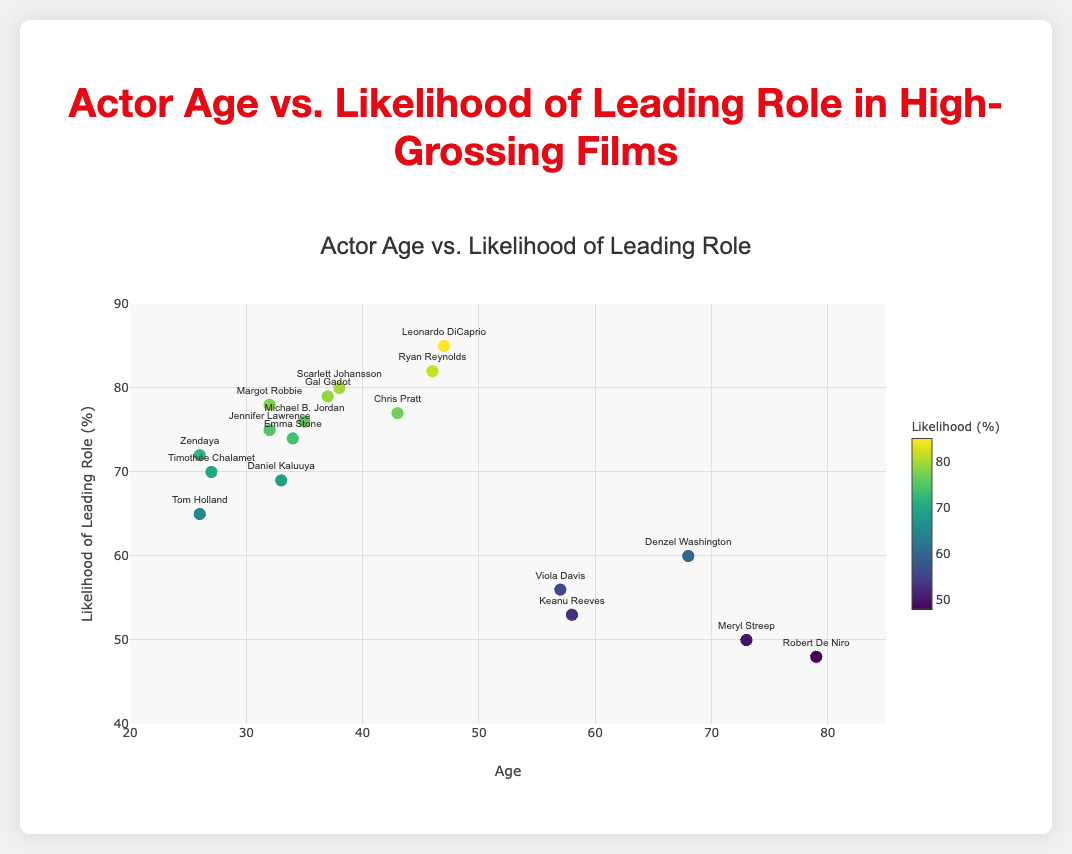what are the age ranges depicted on the x-axis? The x-axis labeled 'Age' ranges from 20 to 85 based on its axis ticks and grid lines.
Answer: 20 to 85 Which actor has the highest likelihood of being cast in a leading role? By identifying the highest y-axis value and reading the corresponding text label, we see Leonardo DiCaprio's likelihood of 85% is the highest.
Answer: Leonardo DiCaprio How many actors are younger than 30 years old? From the plotted points, actors younger than 30 include Tom Holland, Timothée Chalamet, and Zendaya, totaling 3 actors.
Answer: 3 What is the average likelihood of being cast in a leading role for actors aged over 70? Among actors over 70 (Meryl Streep and Robert De Niro), their likelihoods are 50% and 48%. Therefore, the average is (50 + 48) / 2 = 49%.
Answer: 49% Compare the likelihood of being cast in a lead role between actors aged 40-50 and those aged 30-40. Which group has a higher average likelihood? Actors aged 40-50 are Leonardo DiCaprio, Chris Pratt, and Ryan Reynolds with likelihoods of 85%, 77%, and 82% (average (85+77+82)/3 = 81.3%). For actors aged 30-40, there are Jennifer Lawrence, Scarlett Johansson, Margot Robbie, Emma Stone, Daniel Kaluuya, Michael B. Jordan, and Gal Gadot with likelihoods of 75%, 80%, 78%, 74%, 69%, 76%, and 79% (average (75+80+78+74+69+76+79)/7 = 75.9%). Thus, the 40-50 age group has a higher average likelihood.
Answer: Actors aged 40-50 Who is the youngest actor to have more than 70% likelihood of being cast in a leading role? By looking at the points above 70% likelihood, the youngest actor is Zendaya, aged 26 with a 72% likelihood.
Answer: Zendaya Which actor over 50 years of age has the highest likelihood of being cast in a lead role? By examining plotted points for actors over 50, Viola Davis has the highest likelihood at 56%.
Answer: Viola Davis What is the median age among actors in the dataset? Listing the ages in ascending order: 26, 26, 27, 32, 32, 33, 34, 35, 37, 38, 43, 46, 47, 57, 58, 68, 73, 79. With 18 actors, the median age, which is the average of the 9th and 10th ages, is (37+38)/2 = 37.5.
Answer: 37.5 